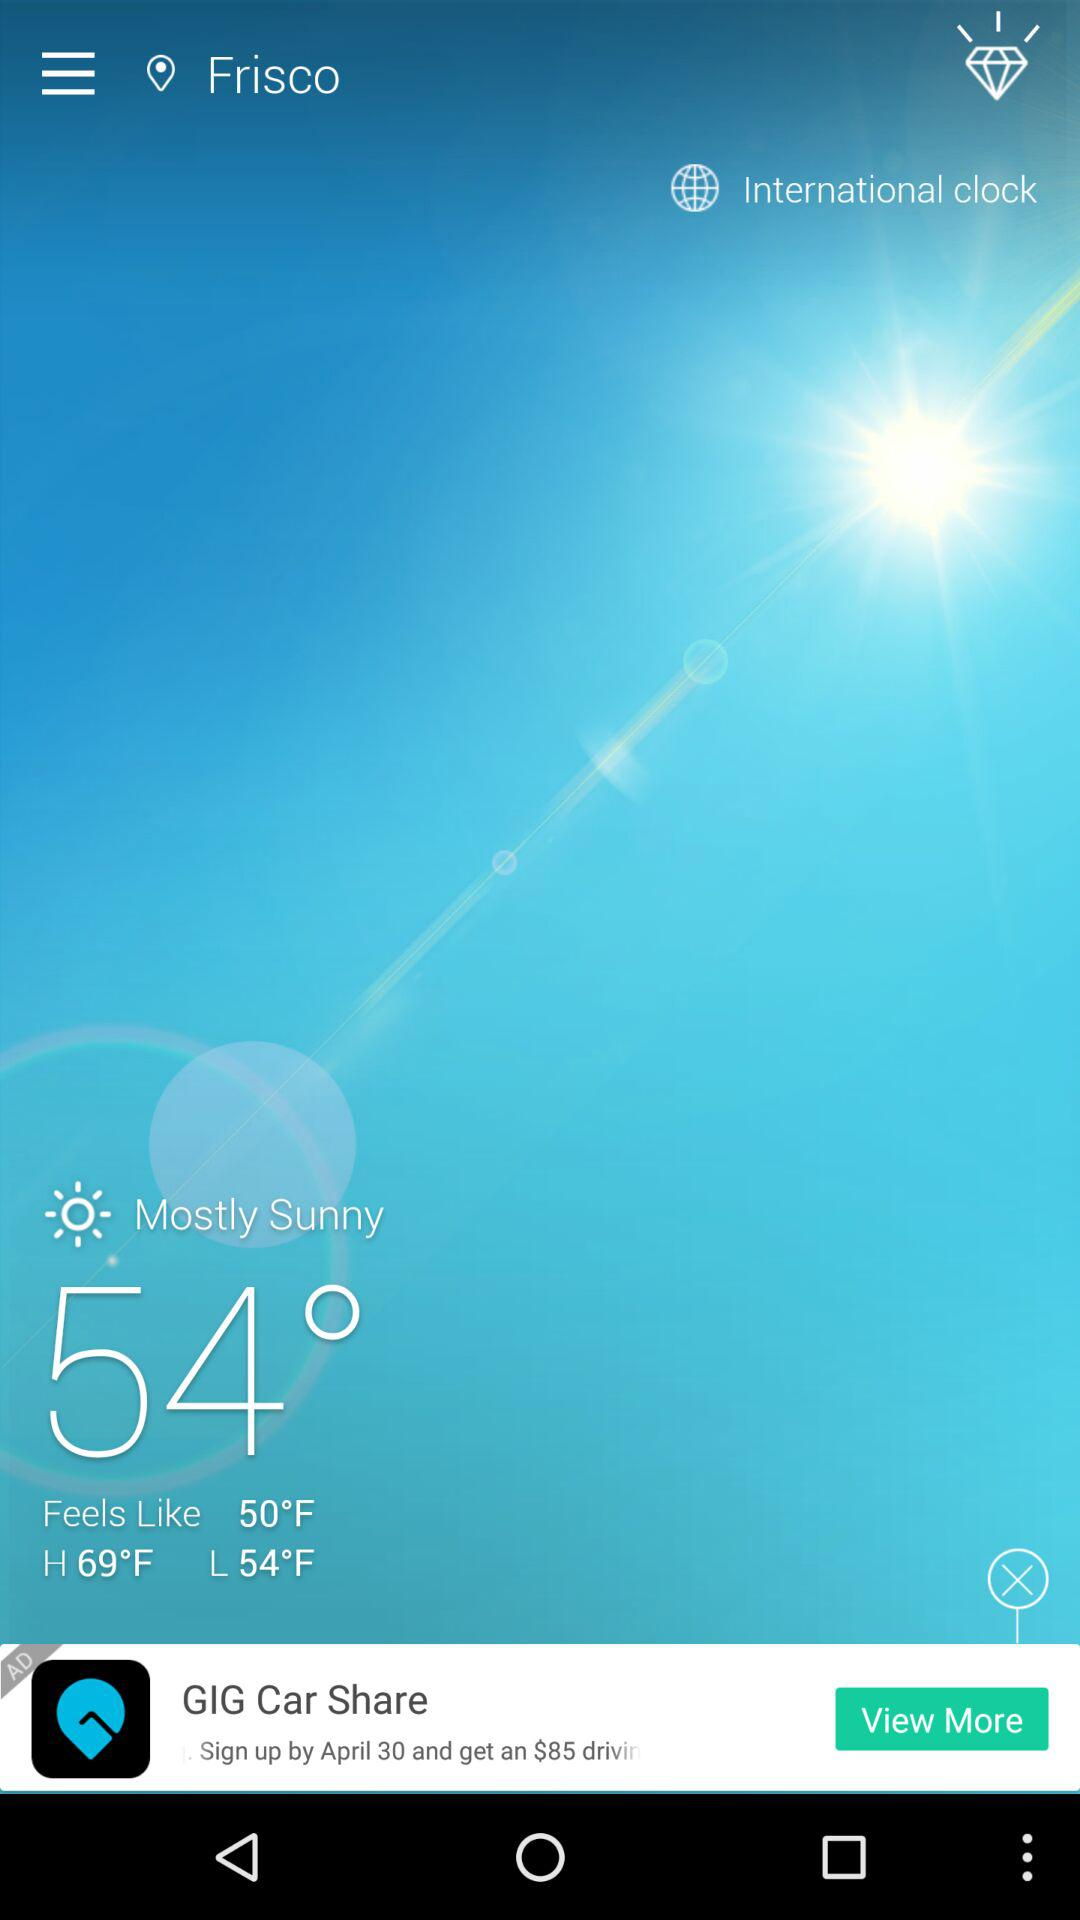What is the weather in Frisco? The weather is mostly sunny. 